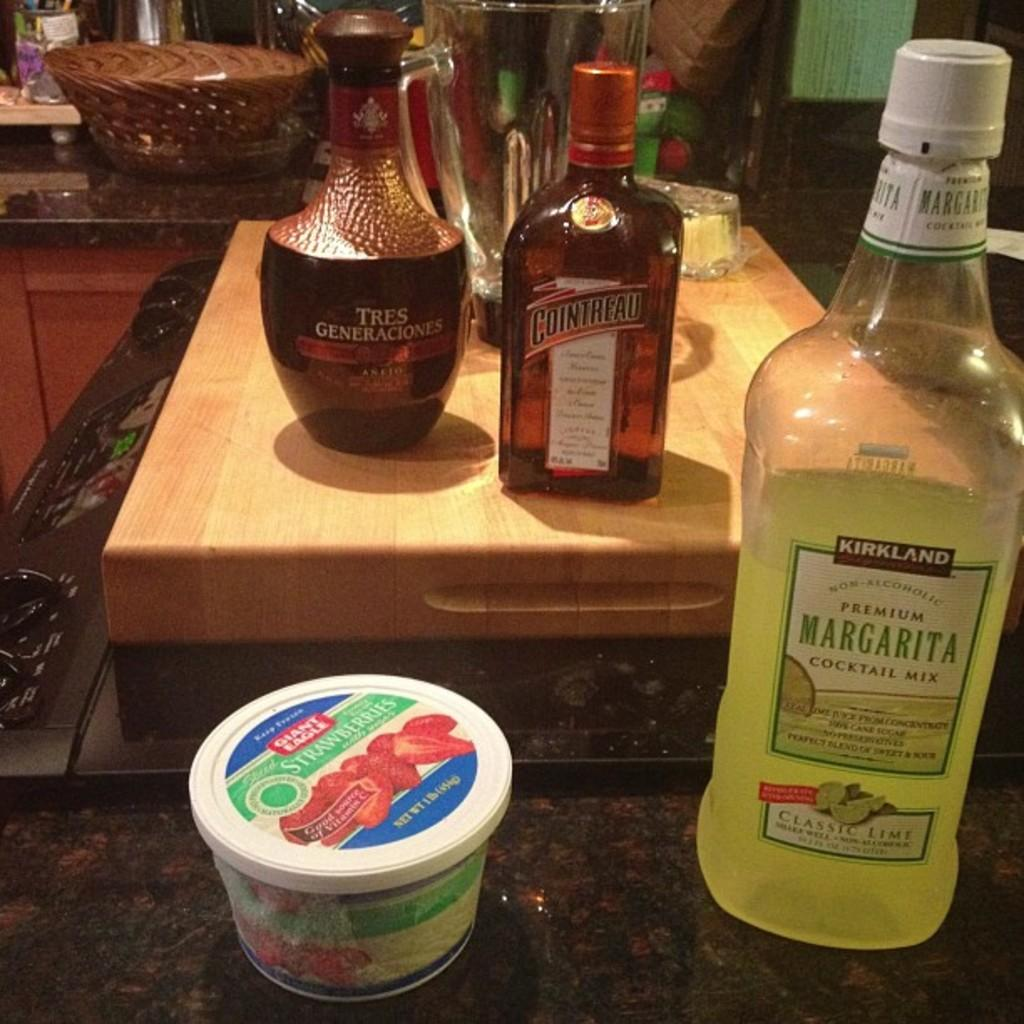<image>
Give a short and clear explanation of the subsequent image. A bottle of Kirkland brand margarita sits next to a container of strawberries. 